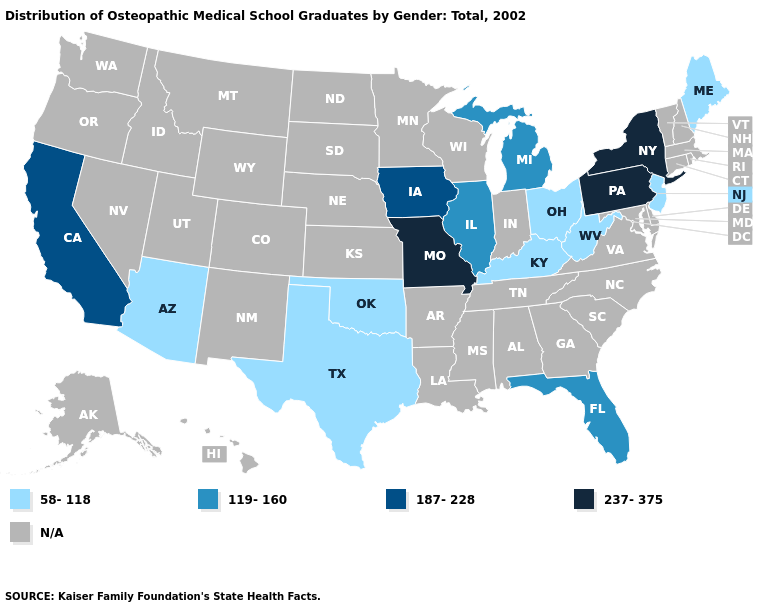Among the states that border Connecticut , which have the highest value?
Short answer required. New York. What is the value of Maine?
Write a very short answer. 58-118. What is the value of Idaho?
Quick response, please. N/A. Name the states that have a value in the range 58-118?
Concise answer only. Arizona, Kentucky, Maine, New Jersey, Ohio, Oklahoma, Texas, West Virginia. What is the lowest value in states that border Nevada?
Quick response, please. 58-118. Name the states that have a value in the range 58-118?
Quick response, please. Arizona, Kentucky, Maine, New Jersey, Ohio, Oklahoma, Texas, West Virginia. What is the value of Colorado?
Write a very short answer. N/A. What is the highest value in states that border Georgia?
Quick response, please. 119-160. What is the value of Virginia?
Be succinct. N/A. Does the map have missing data?
Be succinct. Yes. What is the highest value in states that border New Jersey?
Short answer required. 237-375. What is the value of Georgia?
Answer briefly. N/A. 